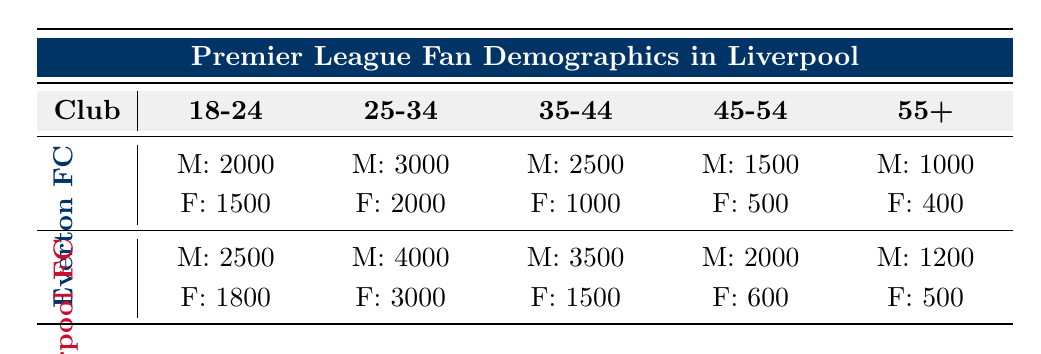What is the total number of male fans for Everton FC? The number of male fans for Everton FC across all age groups is: 2000 (18-24) + 3000 (25-34) + 2500 (35-44) + 1500 (45-54) + 1000 (55+) = 10000.
Answer: 10000 How many female fans does Liverpool FC have in the 35-44 age group? According to the data, Liverpool FC has 1500 female fans in the 35-44 age group.
Answer: 1500 True or False: Everton FC has more female fans aged 25-34 than Liverpool FC. Everton FC has 2000 female fans aged 25-34, while Liverpool FC has 3000 female fans in the same age group. Since 2000 is less than 3000, the statement is false.
Answer: False What is the average number of male fans across all age groups for both clubs? For Everton FC, the total male fans are 10000 and for Liverpool FC, the total male fans are 14000. The average for both clubs is (10000 + 14000) / 2 = 12000.
Answer: 12000 Which age group has the highest number of female fans for Everton FC? The female fans for Everton FC are: 1500 (18-24), 2000 (25-34), 1000 (35-44), 500 (45-54), and 400 (55+). The highest number is 2000 in the 25-34 age group.
Answer: 25-34 How many more male fans does Liverpool FC have than Everton FC in the 45-54 age group? For Everton FC, there are 1500 male fans and for Liverpool FC, there are 2000 male fans in the 45-54 age group. The difference is 2000 - 1500 = 500.
Answer: 500 What percentage of Liverpool FC's fans in the 18-24 age group are female? Liverpool FC has 1800 female fans out of a total of 4300 (2500 male + 1800 female) in the 18-24 age group. The percentage is (1800 / 4300) * 100 ≈ 41.86%.
Answer: 41.86% True or False: The number of male fans in the 25-34 age group for Everton FC is greater than those for Liverpool FC. Everton FC has 3000 male fans while Liverpool FC has 4000 male fans in the 25-34 age group. Since 3000 is less than 4000, the statement is false.
Answer: False 